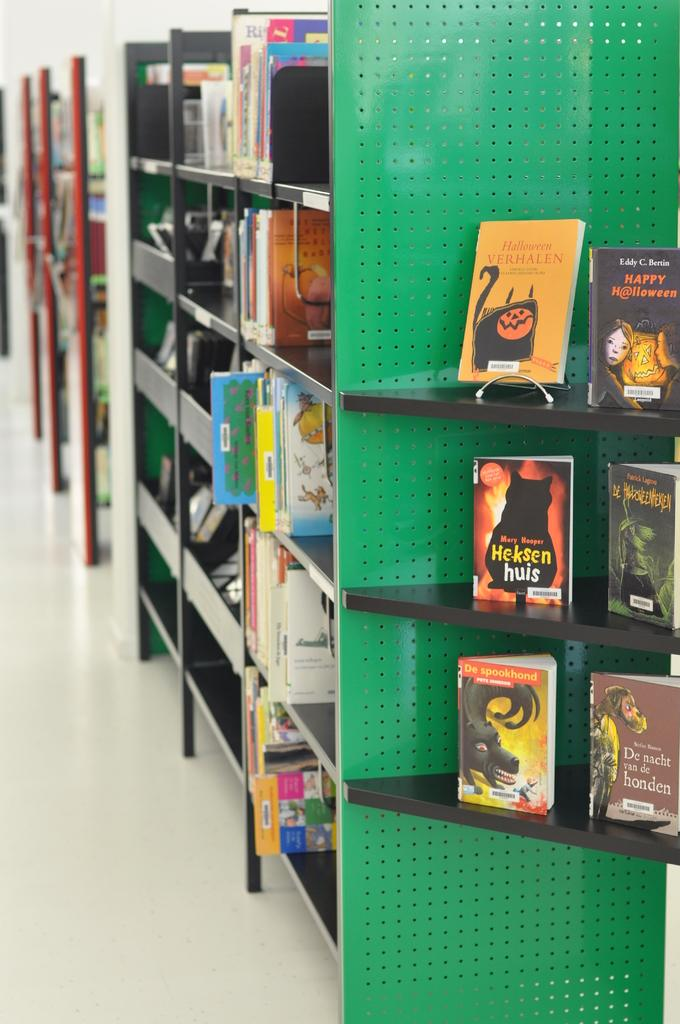<image>
Give a short and clear explanation of the subsequent image. a book is orange and has the word Halloween on it 